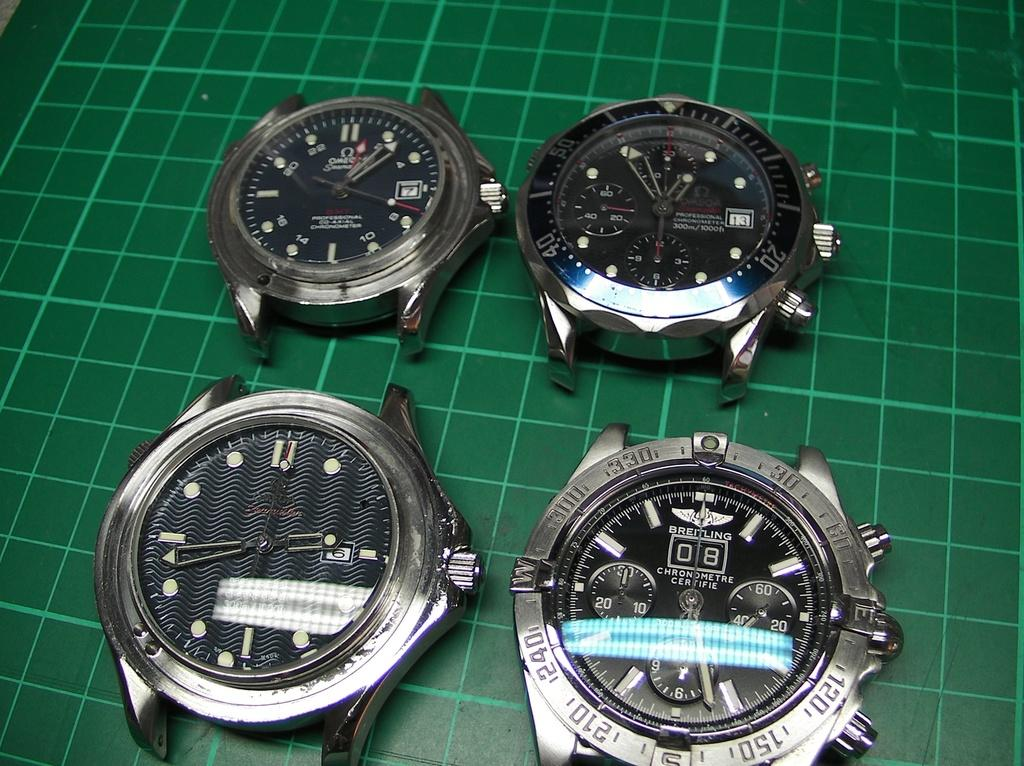<image>
Write a terse but informative summary of the picture. Four strapless watches, one by Breitling on a green graph. 